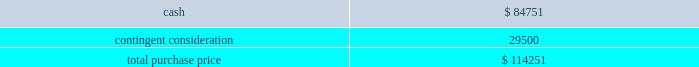Table of contents the company concluded that the acquisition of sentinelle medical did not represent a material business combination , and therefore , no pro forma financial information has been provided herein .
Subsequent to the acquisition date , the company 2019s results of operations include the results of sentinelle medical , which is included within the company 2019s breast health reporting segment .
The company accounted for the sentinelle medical acquisition as a purchase of a business under asc 805 .
The purchase price was comprised of an $ 84.8 million cash payment , which was net of certain adjustments , plus three contingent payments up to a maximum of an additional $ 250.0 million in cash .
The contingent payments are based on a multiple of incremental revenue growth during the two-year period following the completion of the acquisition as follows : six months after acquisition , 12 months after acquisition , and 24 months after acquisition .
Pursuant to asc 805 , the company recorded its estimate of the fair value of the contingent consideration liability based on future revenue projections of the sentinelle medical business under various potential scenarios and weighted probability assumptions of these outcomes .
As of the date of acquisition , these cash flow projections were discounted using a rate of 16.5% ( 16.5 % ) .
The discount rate is based on the weighted-average cost of capital of the acquired business plus a credit risk premium for non-performance risk related to the liability pursuant to asc 820 .
This analysis resulted in an initial contingent consideration liability of $ 29.5 million , which will be adjusted periodically as a component of operating expenses based on changes in the fair value of the liability driven by the accretion of the liability for the time value of money and changes in the assumptions pertaining to the achievement of the defined revenue growth milestones .
This fair value measurement was based on significant inputs not observable in the market and thus represented a level 3 measurement as defined in asc during each quarter in fiscal 2011 , the company has re-evaluated its assumptions and updated the revenue and probability assumptions for future earn-out periods and lowered its projections .
As a result of these adjustments , which were partially offset by the accretion of the liability , and using a current discount rate of approximately 17.0% ( 17.0 % ) , the company recorded a reversal of expense of $ 14.3 million in fiscal 2011 to record the contingent consideration liability at fair value .
In addition , during the second quarter of fiscal 2011 , the first earn-out period ended , and the company adjusted the fair value of the contingent consideration liability for actual results during the earn-out period .
This payment of $ 4.3 million was made in the third quarter of fiscal 2011 .
At september 24 , 2011 , the fair value of the liability is $ 10.9 million .
The company did not issue any equity awards in connection with this acquisition .
The company incurred third-party transaction costs of $ 1.2 million , which were expensed within general and administrative expenses in fiscal 2010 .
The purchase price was as follows: .
Source : hologic inc , 10-k , november 23 , 2011 powered by morningstar ae document research 2120 the information contained herein may not be copied , adapted or distributed and is not warranted to be accurate , complete or timely .
The user assumes all risks for any damages or losses arising from any use of this information , except to the extent such damages or losses cannot be limited or excluded by applicable law .
Past financial performance is no guarantee of future results. .
What portion of the sentinelle medical's purchase price was paid in cash? 
Computations: (84751 / 114251)
Answer: 0.7418. 